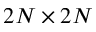<formula> <loc_0><loc_0><loc_500><loc_500>2 N \times 2 N</formula> 